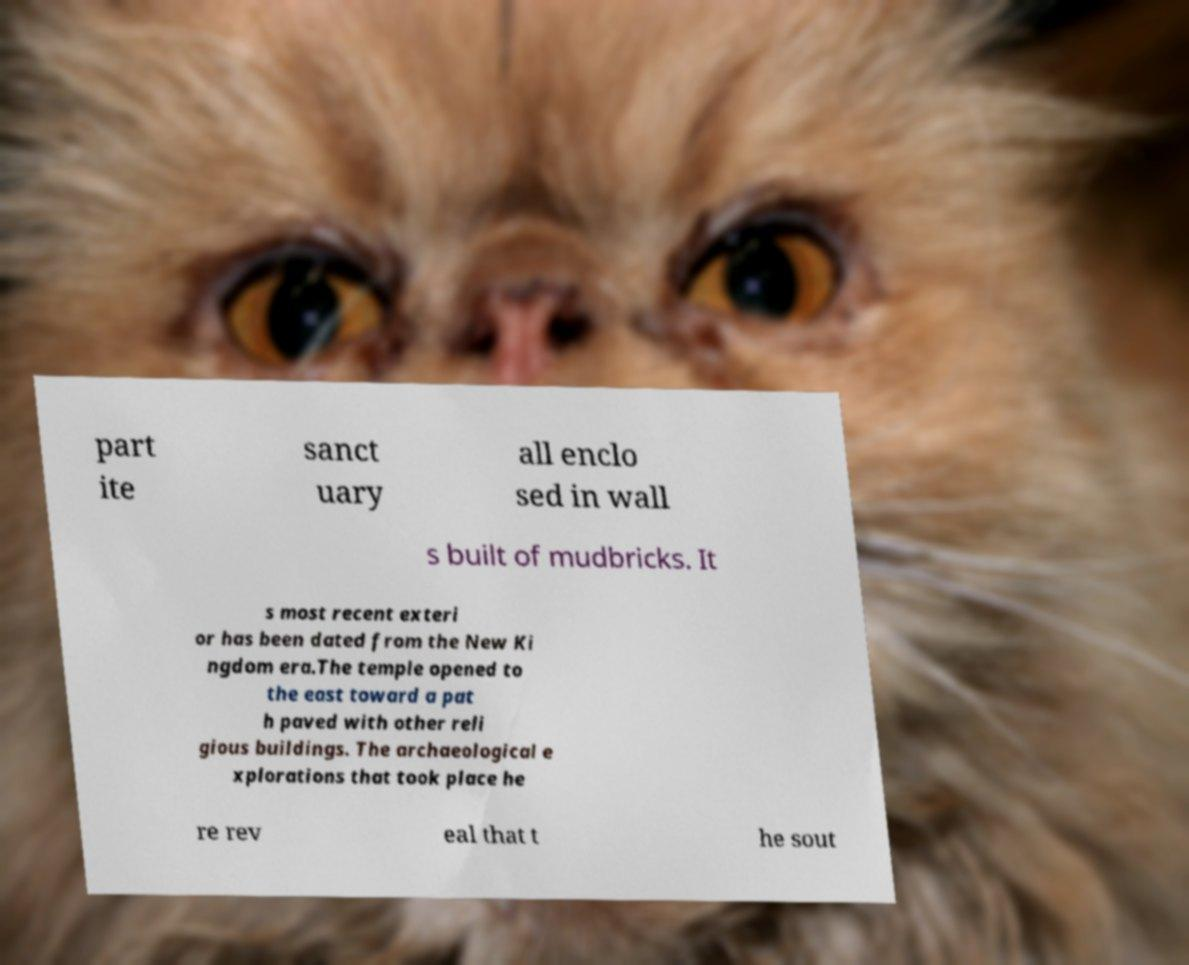Can you read and provide the text displayed in the image?This photo seems to have some interesting text. Can you extract and type it out for me? part ite sanct uary all enclo sed in wall s built of mudbricks. It s most recent exteri or has been dated from the New Ki ngdom era.The temple opened to the east toward a pat h paved with other reli gious buildings. The archaeological e xplorations that took place he re rev eal that t he sout 